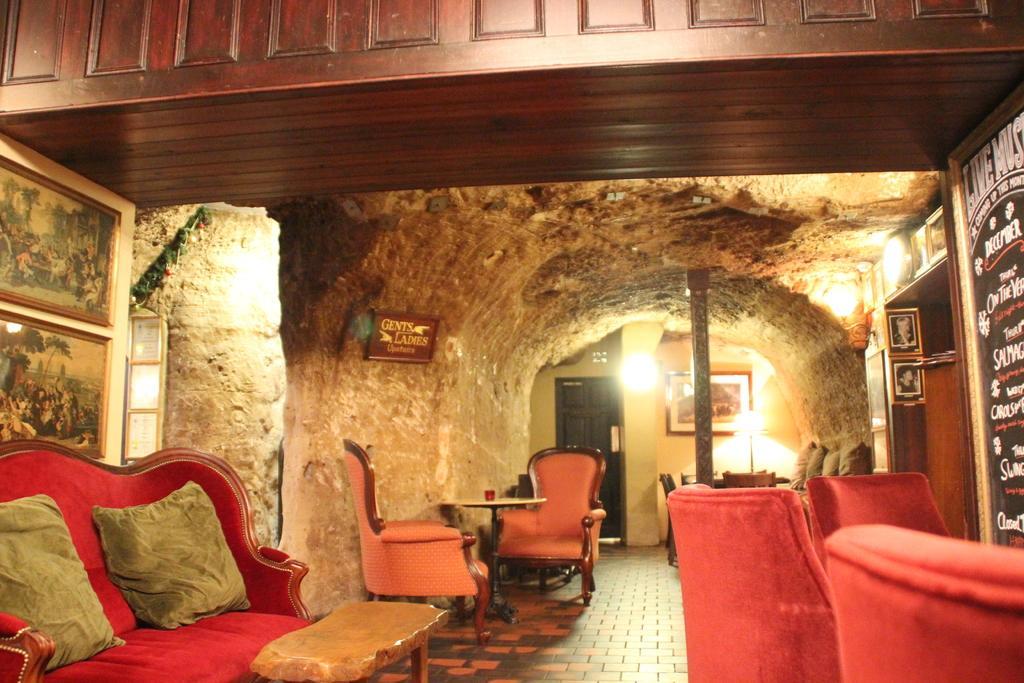How would you summarize this image in a sentence or two? In this image I can see couple of chairs, a light, a pole and other objects on the floor. 